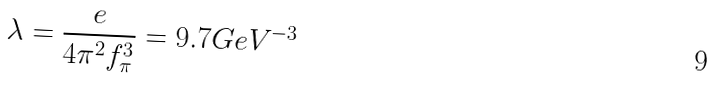<formula> <loc_0><loc_0><loc_500><loc_500>\lambda = \frac { e } { 4 \pi ^ { 2 } f _ { \pi } ^ { 3 } } = 9 . 7 G e V ^ { - 3 }</formula> 